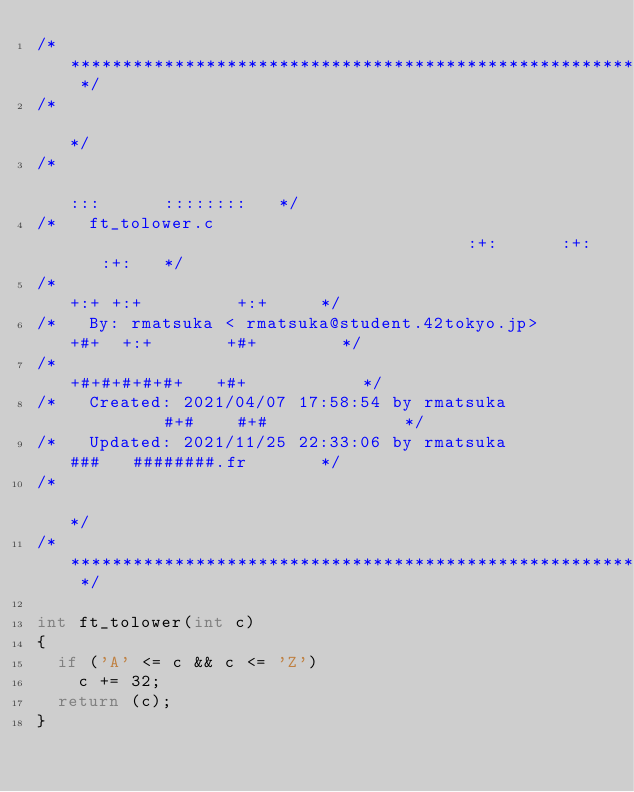Convert code to text. <code><loc_0><loc_0><loc_500><loc_500><_C_>/* ************************************************************************** */
/*                                                                            */
/*                                                        :::      ::::::::   */
/*   ft_tolower.c                                       :+:      :+:    :+:   */
/*                                                    +:+ +:+         +:+     */
/*   By: rmatsuka < rmatsuka@student.42tokyo.jp>    +#+  +:+       +#+        */
/*                                                +#+#+#+#+#+   +#+           */
/*   Created: 2021/04/07 17:58:54 by rmatsuka          #+#    #+#             */
/*   Updated: 2021/11/25 22:33:06 by rmatsuka         ###   ########.fr       */
/*                                                                            */
/* ************************************************************************** */

int	ft_tolower(int c)
{
	if ('A' <= c && c <= 'Z')
		c += 32;
	return (c);
}
</code> 